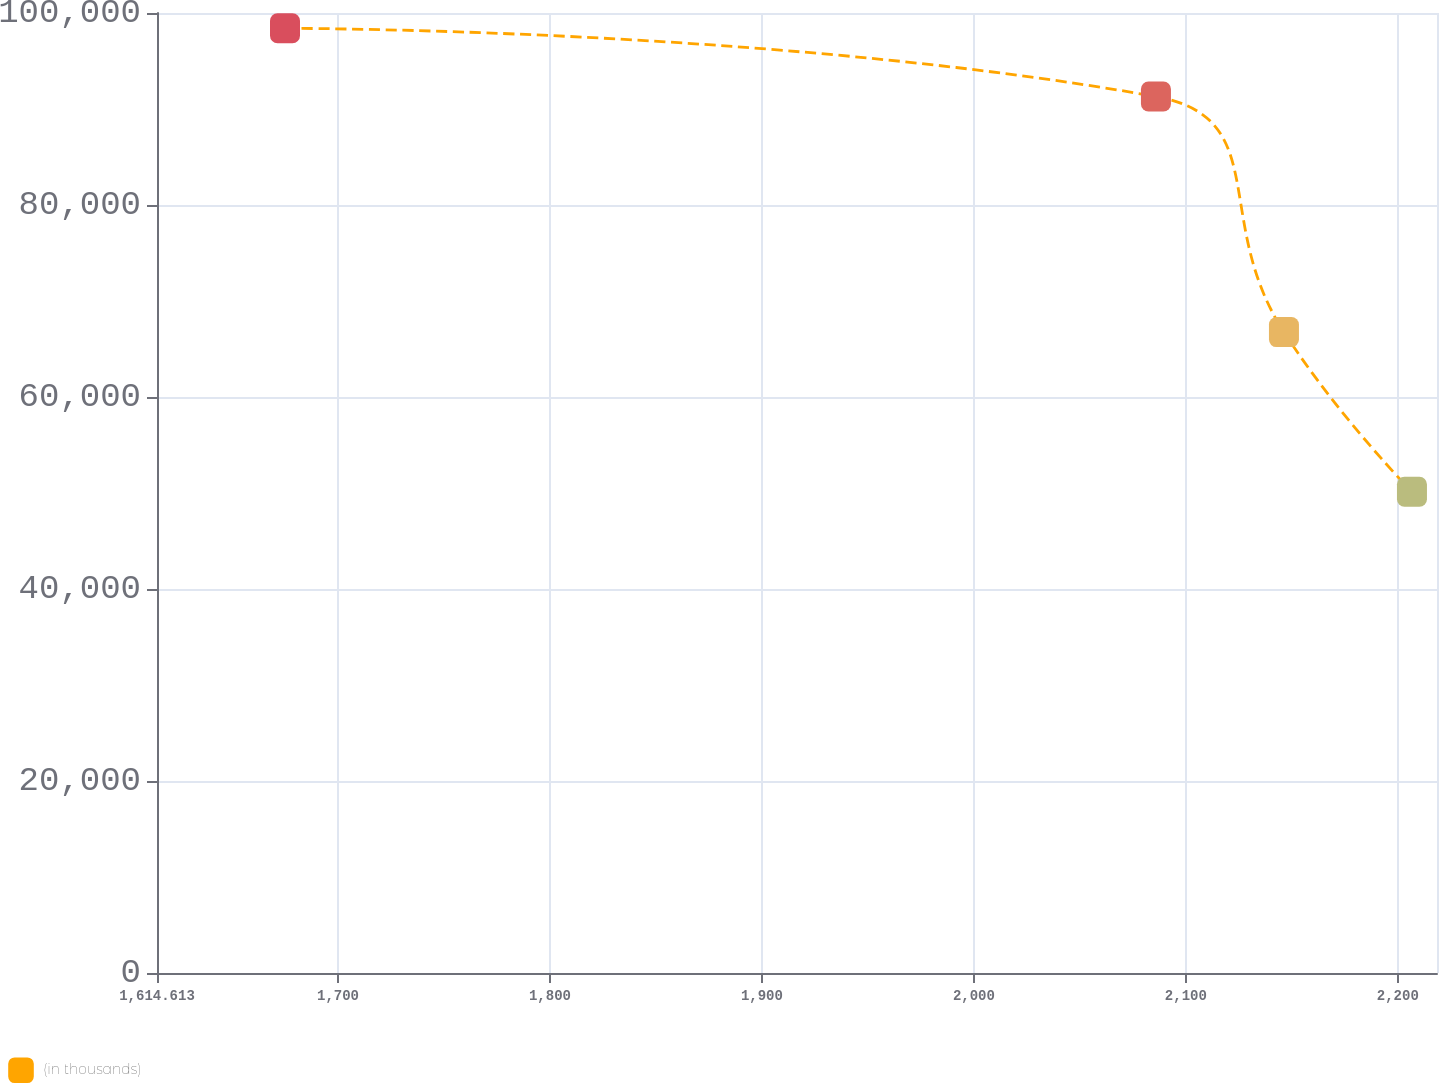<chart> <loc_0><loc_0><loc_500><loc_500><line_chart><ecel><fcel>(in thousands)<nl><fcel>1675<fcel>98404.5<nl><fcel>2085.89<fcel>91296<nl><fcel>2146.28<fcel>66759.3<nl><fcel>2206.67<fcel>50125.5<nl><fcel>2278.87<fcel>24790.3<nl></chart> 